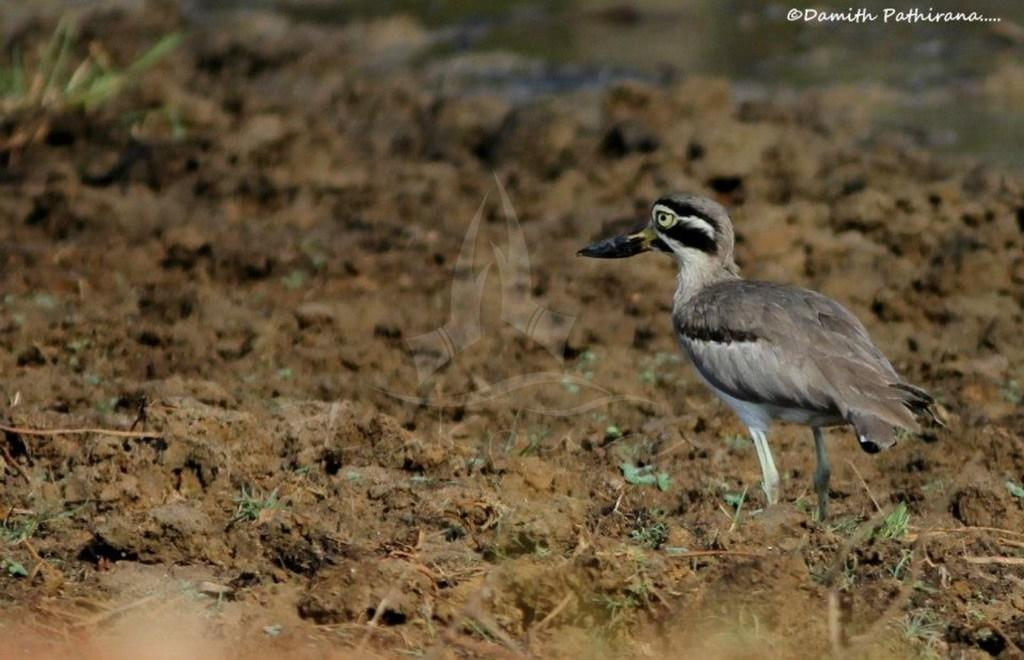What is the main subject in the center of the image? There is a bird in the center of the image. What can be seen at the bottom of the image? There is soil at the bottom of the image. Where is the text located in the image? The text is in the top right corner of the image. Is there an oven visible in the image? No, there is no oven present in the image. Does the image provide evidence of the existence of sheep? No, there is no mention or indication of sheep in the image. 